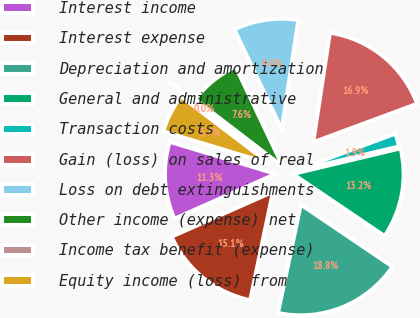<chart> <loc_0><loc_0><loc_500><loc_500><pie_chart><fcel>Interest income<fcel>Interest expense<fcel>Depreciation and amortization<fcel>General and administrative<fcel>Transaction costs<fcel>Gain (loss) on sales of real<fcel>Loss on debt extinguishments<fcel>Other income (expense) net<fcel>Income tax benefit (expense)<fcel>Equity income (loss) from<nl><fcel>11.31%<fcel>15.07%<fcel>18.83%<fcel>13.19%<fcel>1.92%<fcel>16.95%<fcel>9.44%<fcel>7.56%<fcel>0.05%<fcel>5.68%<nl></chart> 